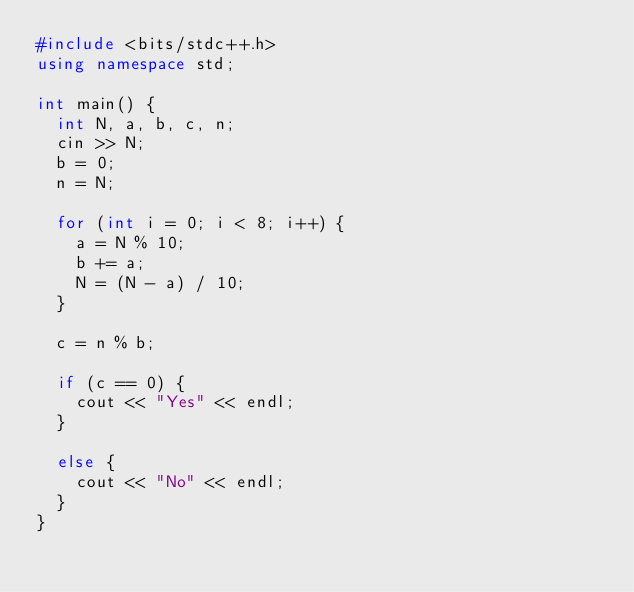Convert code to text. <code><loc_0><loc_0><loc_500><loc_500><_C++_>#include <bits/stdc++.h>
using namespace std;

int main() {
  int N, a, b, c, n;
  cin >> N;
  b = 0;
  n = N;
  
  for (int i = 0; i < 8; i++) {
    a = N % 10;
    b += a;
    N = (N - a) / 10;
  }
  
  c = n % b;
  
  if (c == 0) {
    cout << "Yes" << endl;
  }
  
  else {
    cout << "No" << endl;
  }
}</code> 